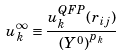<formula> <loc_0><loc_0><loc_500><loc_500>u _ { k } ^ { \infty } \equiv \frac { u _ { k } ^ { Q F P } ( r _ { i j } ) } { { ( Y ^ { 0 } ) } ^ { p _ { k } } }</formula> 